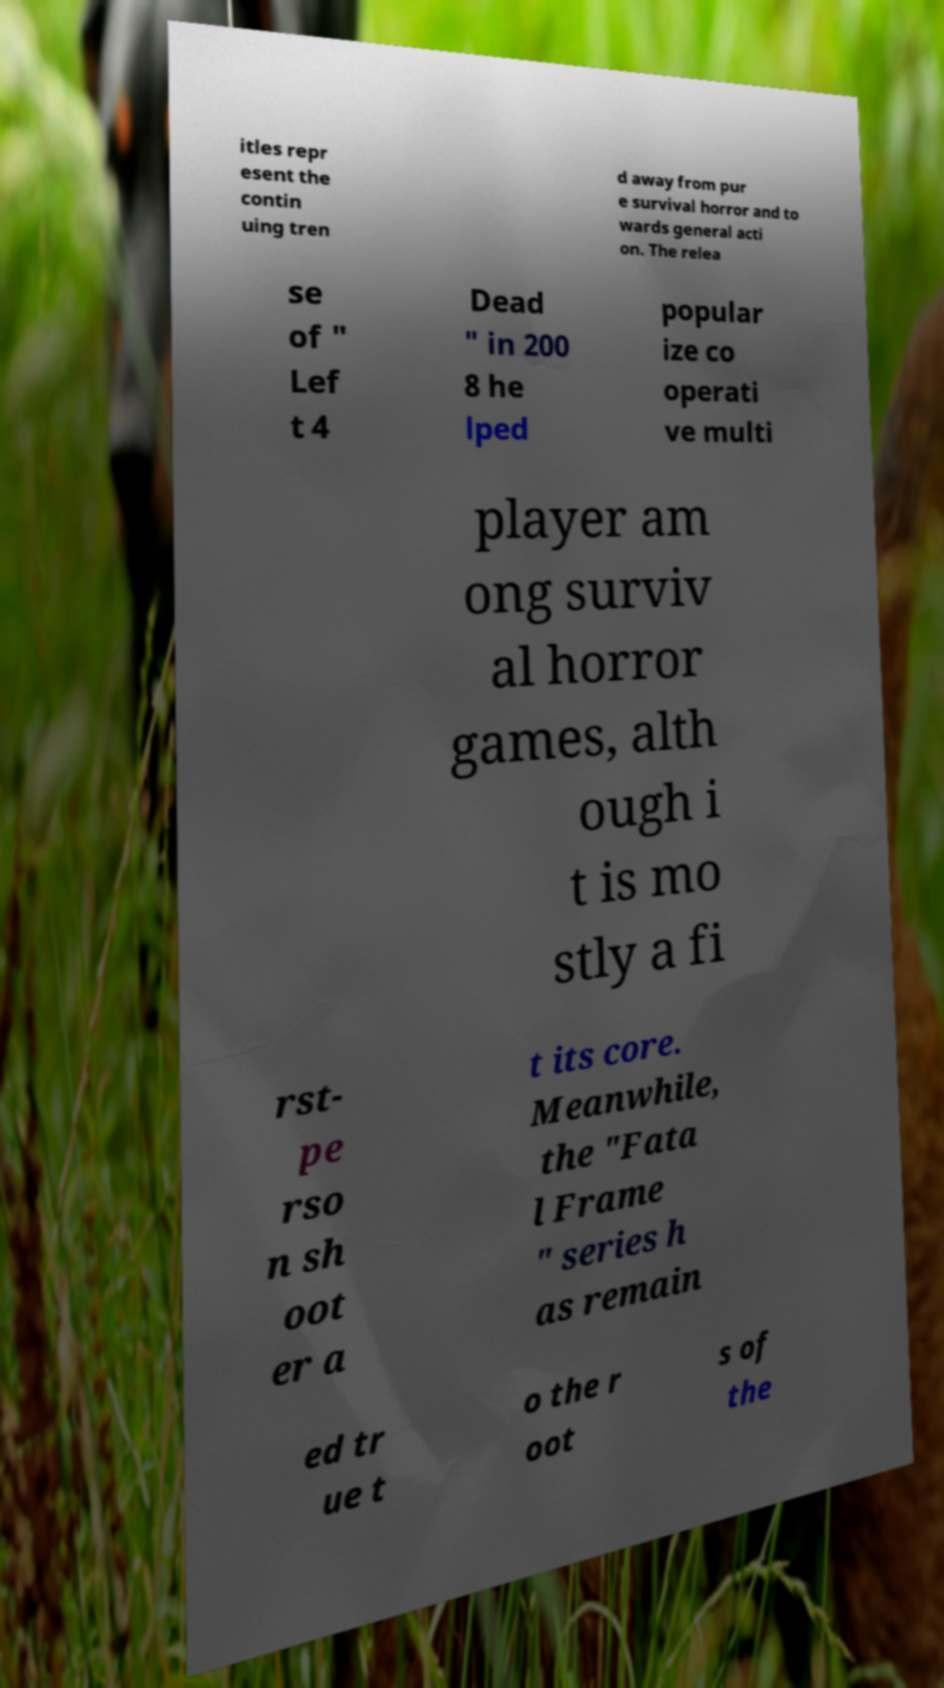Please identify and transcribe the text found in this image. itles repr esent the contin uing tren d away from pur e survival horror and to wards general acti on. The relea se of " Lef t 4 Dead " in 200 8 he lped popular ize co operati ve multi player am ong surviv al horror games, alth ough i t is mo stly a fi rst- pe rso n sh oot er a t its core. Meanwhile, the "Fata l Frame " series h as remain ed tr ue t o the r oot s of the 